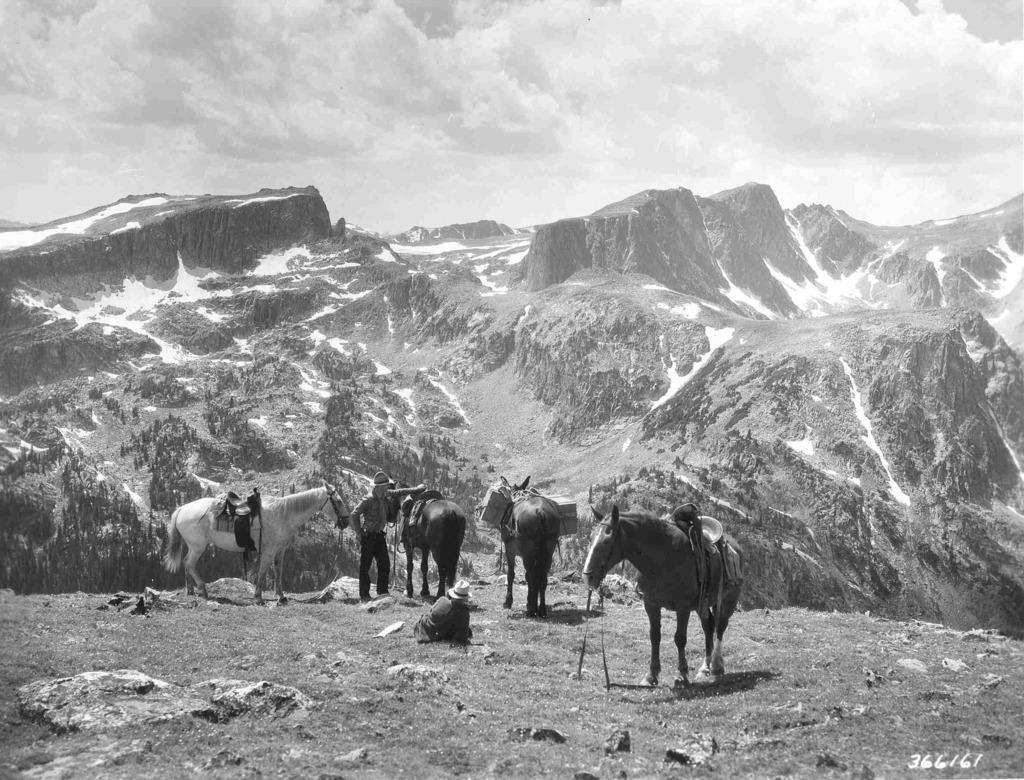Could you give a brief overview of what you see in this image? There is a person standing and placing a hand on the horse, on the grass on the ground of a hill, along with other three horses which are on the ground and a person who is sitting on the ground. In the background, there are mountains and there are clouds in the sky. 